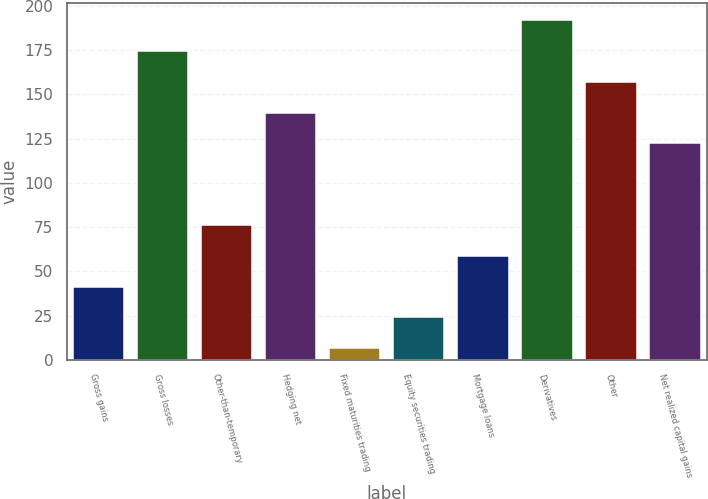<chart> <loc_0><loc_0><loc_500><loc_500><bar_chart><fcel>Gross gains<fcel>Gross losses<fcel>Other-than-temporary<fcel>Hedging net<fcel>Fixed maturities trading<fcel>Equity securities trading<fcel>Mortgage loans<fcel>Derivatives<fcel>Other<fcel>Net realized capital gains<nl><fcel>41.46<fcel>174.44<fcel>76.22<fcel>139.68<fcel>6.7<fcel>24.08<fcel>58.84<fcel>191.82<fcel>157.06<fcel>122.3<nl></chart> 